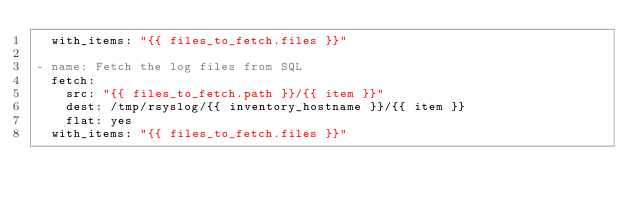Convert code to text. <code><loc_0><loc_0><loc_500><loc_500><_YAML_>  with_items: "{{ files_to_fetch.files }}"

- name: Fetch the log files from SQL
  fetch:
    src: "{{ files_to_fetch.path }}/{{ item }}"
    dest: /tmp/rsyslog/{{ inventory_hostname }}/{{ item }}
    flat: yes
  with_items: "{{ files_to_fetch.files }}" 
</code> 